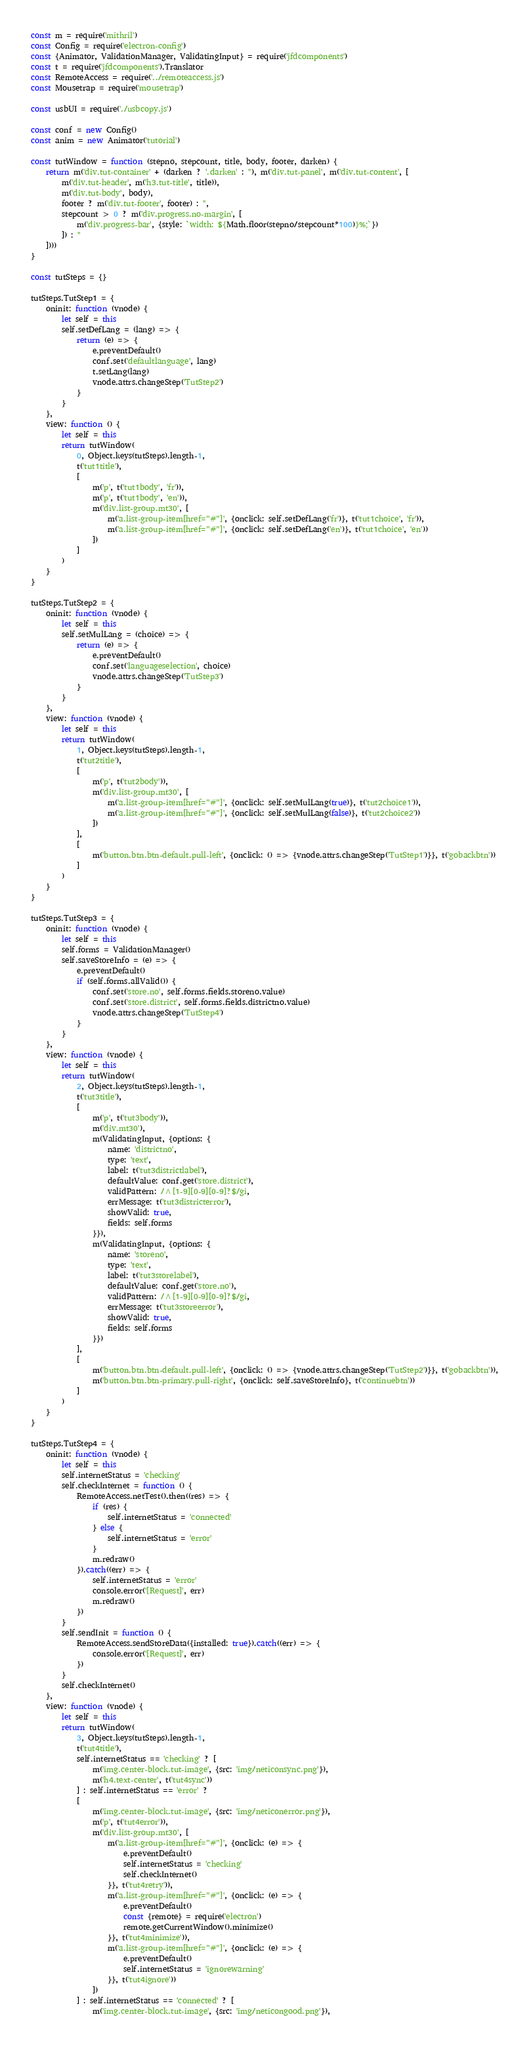<code> <loc_0><loc_0><loc_500><loc_500><_JavaScript_>const m = require('mithril')
const Config = require('electron-config')
const {Animator, ValidationManager, ValidatingInput} = require('jfdcomponents')
const t = require('jfdcomponents').Translator
const RemoteAccess = require('../remoteaccess.js')
const Mousetrap = require('mousetrap')

const usbUI = require('./usbcopy.js')

const conf = new Config()
const anim = new Animator('tutorial')

const tutWindow = function (stepno, stepcount, title, body, footer, darken) {
    return m('div.tut-container' + (darken ? '.darken' : ''), m('div.tut-panel', m('div.tut-content', [
        m('div.tut-header', m('h3.tut-title', title)),
        m('div.tut-body', body),
        footer ? m('div.tut-footer', footer) : '',
        stepcount > 0 ? m('div.progress.no-margin', [
            m('div.progress-bar', {style: `width: ${Math.floor(stepno/stepcount*100)}%;`})
        ]) : ''
    ])))
}

const tutSteps = {}

tutSteps.TutStep1 = {
    oninit: function (vnode) {
        let self = this
        self.setDefLang = (lang) => {
            return (e) => {
                e.preventDefault()
                conf.set('defaultlanguage', lang)
                t.setLang(lang)
                vnode.attrs.changeStep('TutStep2')
            }
        }
    },
    view: function () {
        let self = this
        return tutWindow(
            0, Object.keys(tutSteps).length-1,
            t('tut1title'), 
            [
                m('p', t('tut1body', 'fr')),
                m('p', t('tut1body', 'en')),
                m('div.list-group.mt30', [
                    m('a.list-group-item[href="#"]', {onclick: self.setDefLang('fr')}, t('tut1choice', 'fr')),
                    m('a.list-group-item[href="#"]', {onclick: self.setDefLang('en')}, t('tut1choice', 'en'))
                ])
            ]
        )
    }
}

tutSteps.TutStep2 = {
    oninit: function (vnode) {
        let self = this
        self.setMulLang = (choice) => {
            return (e) => {
                e.preventDefault()
                conf.set('languageselection', choice)
                vnode.attrs.changeStep('TutStep3')
            }
        }
    },
    view: function (vnode) {
        let self = this
        return tutWindow(
            1, Object.keys(tutSteps).length-1,
            t('tut2title'),
            [
                m('p', t('tut2body')),
                m('div.list-group.mt30', [
                    m('a.list-group-item[href="#"]', {onclick: self.setMulLang(true)}, t('tut2choice1')),
                    m('a.list-group-item[href="#"]', {onclick: self.setMulLang(false)}, t('tut2choice2'))
                ])
            ],
            [
                m('button.btn.btn-default.pull-left', {onclick: () => {vnode.attrs.changeStep('TutStep1')}}, t('gobackbtn'))
            ]
        )
    }
}

tutSteps.TutStep3 = {
    oninit: function (vnode) {
        let self = this
        self.forms = ValidationManager()
        self.saveStoreInfo = (e) => {
            e.preventDefault()
            if (self.forms.allValid()) {
                conf.set('store.no', self.forms.fields.storeno.value)
                conf.set('store.district', self.forms.fields.districtno.value)
                vnode.attrs.changeStep('TutStep4')
            }
        }
    },
    view: function (vnode) {
        let self = this
        return tutWindow(
            2, Object.keys(tutSteps).length-1,
            t('tut3title'),
            [
                m('p', t('tut3body')),
                m('div.mt30'),
                m(ValidatingInput, {options: {
                    name: 'districtno',
                    type: 'text',
                    label: t('tut3districtlabel'),
                    defaultValue: conf.get('store.district'),
                    validPattern: /^[1-9][0-9][0-9]?$/gi,
                    errMessage: t('tut3districterror'),
                    showValid: true,
                    fields: self.forms
                }}),
                m(ValidatingInput, {options: {
                    name: 'storeno',
                    type: 'text',
                    label: t('tut3storelabel'),
                    defaultValue: conf.get('store.no'),
                    validPattern: /^[1-9][0-9][0-9]?$/gi,
                    errMessage: t('tut3storeerror'),
                    showValid: true,
                    fields: self.forms
                }})
            ],
            [
                m('button.btn.btn-default.pull-left', {onclick: () => {vnode.attrs.changeStep('TutStep2')}}, t('gobackbtn')),
                m('button.btn.btn-primary.pull-right', {onclick: self.saveStoreInfo}, t('continuebtn'))
            ]
        )
    }
}

tutSteps.TutStep4 = {
    oninit: function (vnode) {
        let self = this
        self.internetStatus = 'checking'
        self.checkInternet = function () {
            RemoteAccess.netTest().then((res) => {
                if (res) {
                    self.internetStatus = 'connected'
                } else {
                    self.internetStatus = 'error'
                }
                m.redraw()
            }).catch((err) => {
                self.internetStatus = 'error'
                console.error('[Request]', err)
                m.redraw()
            })
        }
        self.sendInit = function () {
            RemoteAccess.sendStoreData({installed: true}).catch((err) => {
                console.error('[Request]', err)
            })
        }
        self.checkInternet()
    },
    view: function (vnode) {
        let self = this
        return tutWindow(
            3, Object.keys(tutSteps).length-1,
            t('tut4title'),
            self.internetStatus == 'checking' ? [
                m('img.center-block.tut-image', {src: 'img/neticonsync.png'}),
                m('h4.text-center', t('tut4sync'))
            ] : self.internetStatus == 'error' ?
            [
                m('img.center-block.tut-image', {src: 'img/neticonerror.png'}),
                m('p', t('tut4error')),
                m('div.list-group.mt30', [
                    m('a.list-group-item[href="#"]', {onclick: (e) => {
                        e.preventDefault()
                        self.internetStatus = 'checking'
                        self.checkInternet()
                    }}, t('tut4retry')),
                    m('a.list-group-item[href="#"]', {onclick: (e) => {
                        e.preventDefault()
                        const {remote} = require('electron')
                        remote.getCurrentWindow().minimize()
                    }}, t('tut4minimize')),
                    m('a.list-group-item[href="#"]', {onclick: (e) => {
                        e.preventDefault()
                        self.internetStatus = 'ignorewarning'
                    }}, t('tut4ignore'))
                ])
            ] : self.internetStatus == 'connected' ? [
                m('img.center-block.tut-image', {src: 'img/neticongood.png'}),</code> 